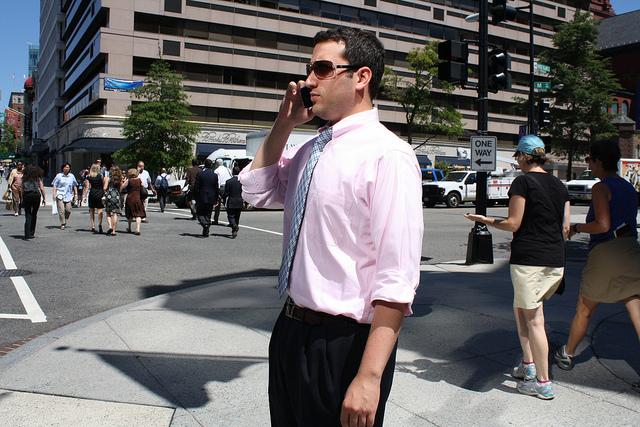Is the man in a crosswalk?
Keep it brief. No. What color is the man's shirt?
Answer briefly. Pink. What just happened to this man?
Quick response, please. Phone call. Is anyone wearing a pair of sunglasses?
Answer briefly. Yes. What is the man talking on?
Concise answer only. Cell phone. 